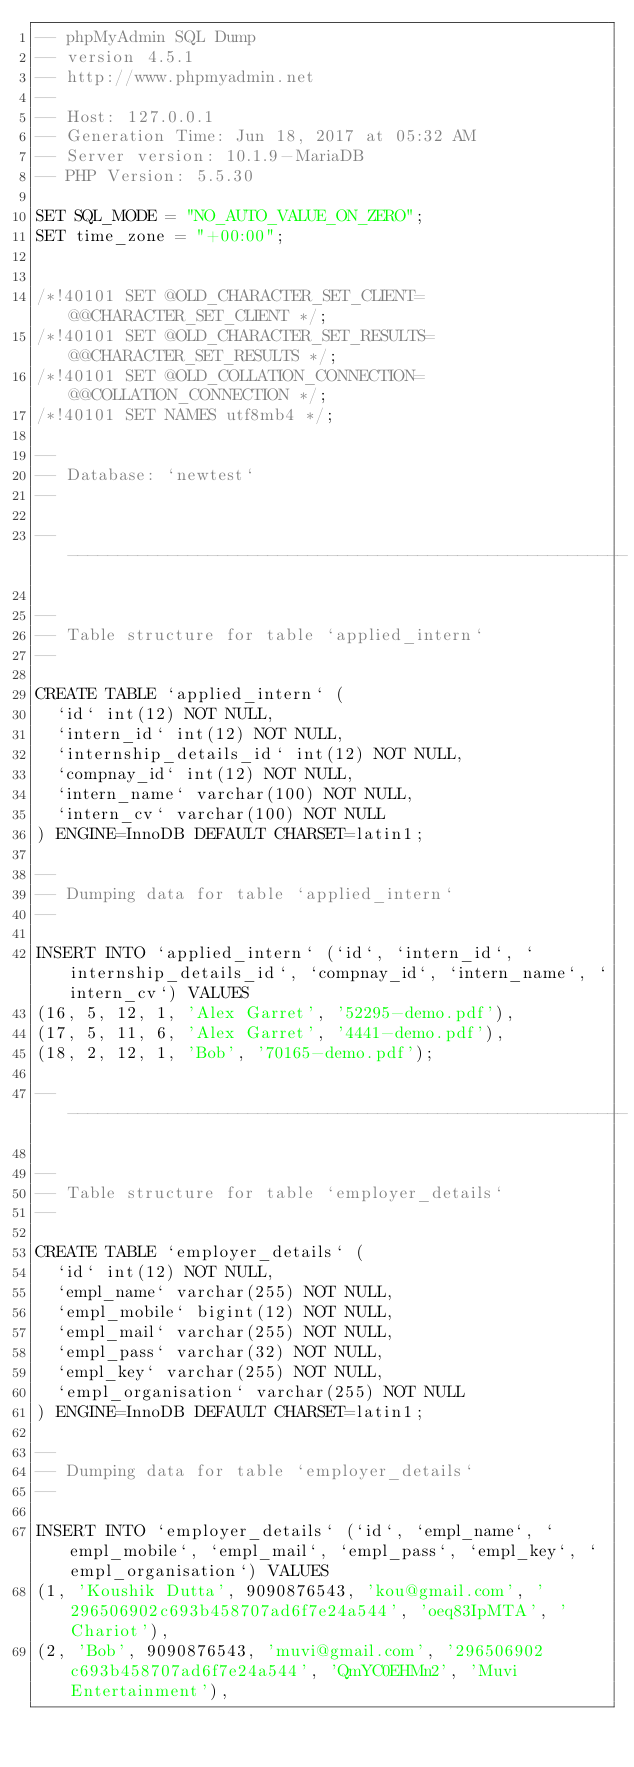<code> <loc_0><loc_0><loc_500><loc_500><_SQL_>-- phpMyAdmin SQL Dump
-- version 4.5.1
-- http://www.phpmyadmin.net
--
-- Host: 127.0.0.1
-- Generation Time: Jun 18, 2017 at 05:32 AM
-- Server version: 10.1.9-MariaDB
-- PHP Version: 5.5.30

SET SQL_MODE = "NO_AUTO_VALUE_ON_ZERO";
SET time_zone = "+00:00";


/*!40101 SET @OLD_CHARACTER_SET_CLIENT=@@CHARACTER_SET_CLIENT */;
/*!40101 SET @OLD_CHARACTER_SET_RESULTS=@@CHARACTER_SET_RESULTS */;
/*!40101 SET @OLD_COLLATION_CONNECTION=@@COLLATION_CONNECTION */;
/*!40101 SET NAMES utf8mb4 */;

--
-- Database: `newtest`
--

-- --------------------------------------------------------

--
-- Table structure for table `applied_intern`
--

CREATE TABLE `applied_intern` (
  `id` int(12) NOT NULL,
  `intern_id` int(12) NOT NULL,
  `internship_details_id` int(12) NOT NULL,
  `compnay_id` int(12) NOT NULL,
  `intern_name` varchar(100) NOT NULL,
  `intern_cv` varchar(100) NOT NULL
) ENGINE=InnoDB DEFAULT CHARSET=latin1;

--
-- Dumping data for table `applied_intern`
--

INSERT INTO `applied_intern` (`id`, `intern_id`, `internship_details_id`, `compnay_id`, `intern_name`, `intern_cv`) VALUES
(16, 5, 12, 1, 'Alex Garret', '52295-demo.pdf'),
(17, 5, 11, 6, 'Alex Garret', '4441-demo.pdf'),
(18, 2, 12, 1, 'Bob', '70165-demo.pdf');

-- --------------------------------------------------------

--
-- Table structure for table `employer_details`
--

CREATE TABLE `employer_details` (
  `id` int(12) NOT NULL,
  `empl_name` varchar(255) NOT NULL,
  `empl_mobile` bigint(12) NOT NULL,
  `empl_mail` varchar(255) NOT NULL,
  `empl_pass` varchar(32) NOT NULL,
  `empl_key` varchar(255) NOT NULL,
  `empl_organisation` varchar(255) NOT NULL
) ENGINE=InnoDB DEFAULT CHARSET=latin1;

--
-- Dumping data for table `employer_details`
--

INSERT INTO `employer_details` (`id`, `empl_name`, `empl_mobile`, `empl_mail`, `empl_pass`, `empl_key`, `empl_organisation`) VALUES
(1, 'Koushik Dutta', 9090876543, 'kou@gmail.com', '296506902c693b458707ad6f7e24a544', 'oeq83IpMTA', 'Chariot'),
(2, 'Bob', 9090876543, 'muvi@gmail.com', '296506902c693b458707ad6f7e24a544', 'QmYC0EHMn2', 'Muvi Entertainment'),</code> 